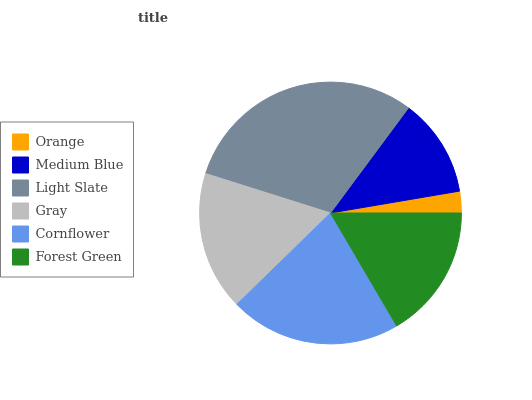Is Orange the minimum?
Answer yes or no. Yes. Is Light Slate the maximum?
Answer yes or no. Yes. Is Medium Blue the minimum?
Answer yes or no. No. Is Medium Blue the maximum?
Answer yes or no. No. Is Medium Blue greater than Orange?
Answer yes or no. Yes. Is Orange less than Medium Blue?
Answer yes or no. Yes. Is Orange greater than Medium Blue?
Answer yes or no. No. Is Medium Blue less than Orange?
Answer yes or no. No. Is Gray the high median?
Answer yes or no. Yes. Is Forest Green the low median?
Answer yes or no. Yes. Is Orange the high median?
Answer yes or no. No. Is Light Slate the low median?
Answer yes or no. No. 